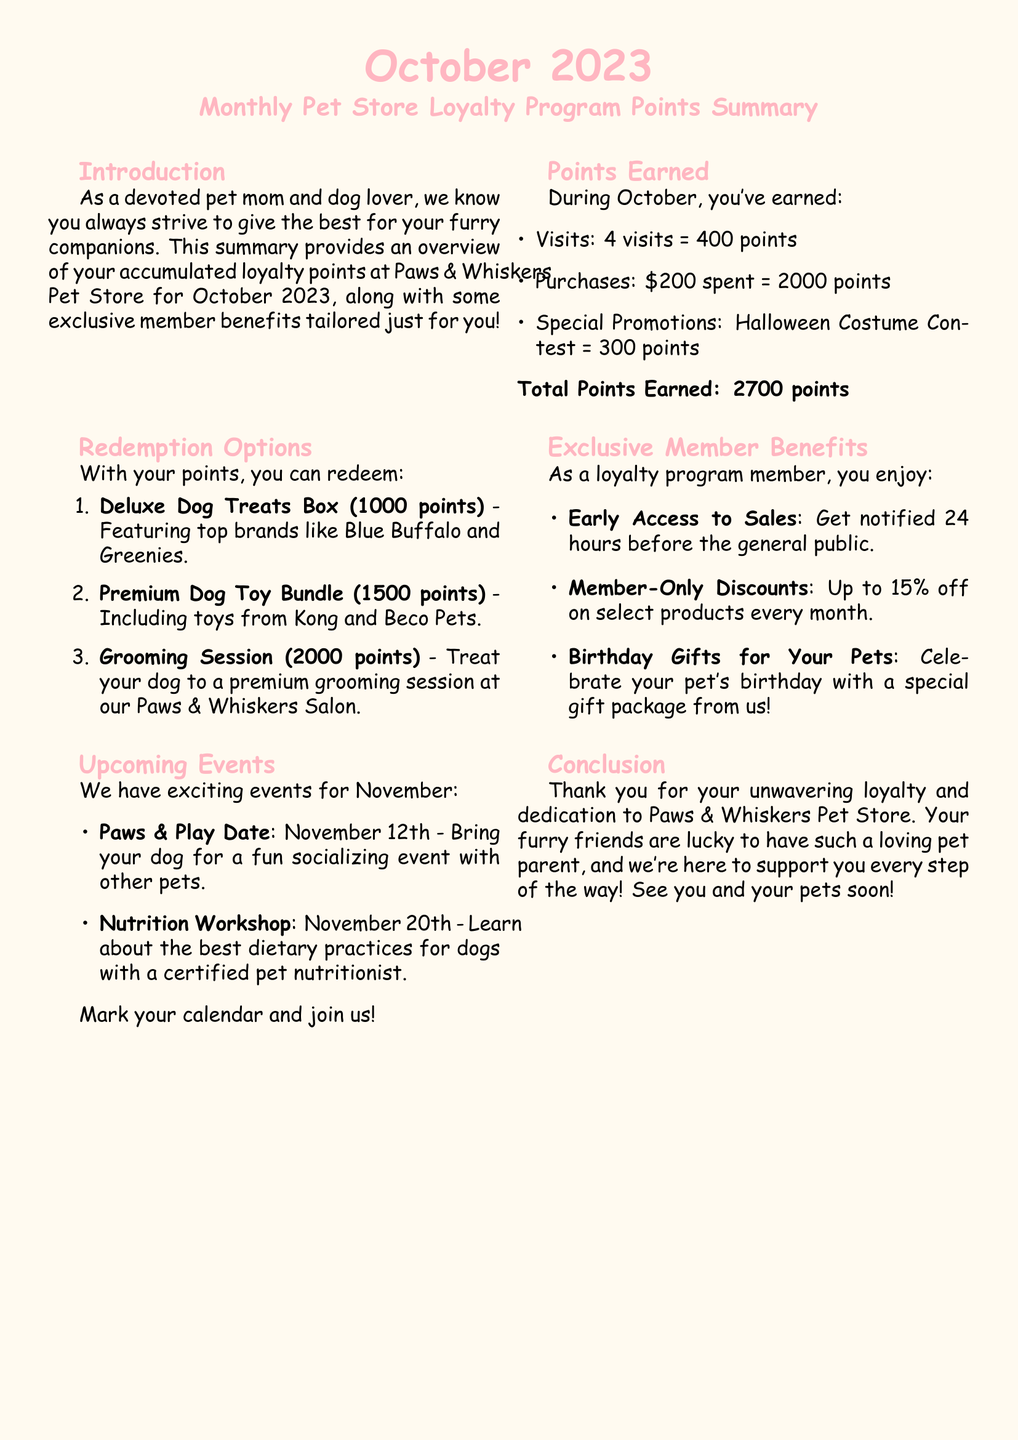What is the total number of points earned in October? The total points earned is the sum of points from visits, purchases, and special promotions: 400 + 2000 + 300 = 2700.
Answer: 2700 points How many visits did you make in October? The document states that there were 4 visits, which earned 400 points.
Answer: 4 visits What are the points required for the Deluxe Dog Treats Box? It specifies that the Deluxe Dog Treats Box can be redeemed for 1000 points.
Answer: 1000 points What exclusive member benefit is related to events? The document mentions "Early Access to Sales" as a benefit that provides early notification about sales.
Answer: Early Access to Sales When is the Nutrition Workshop scheduled? The document lists the Nutrition Workshop date as November 20th.
Answer: November 20th How many points do you need for a Premium Dog Toy Bundle? The document indicates that 1500 points are required for the Premium Dog Toy Bundle.
Answer: 1500 points What special event is happening on November 12th? The event on November 12th is called "Paws & Play Date."
Answer: Paws & Play Date Which two brands are mentioned in the Deluxe Dog Treats Box? The document lists Blue Buffalo and Greenies as brands featured in the Deluxe Dog Treats Box.
Answer: Blue Buffalo and Greenies 